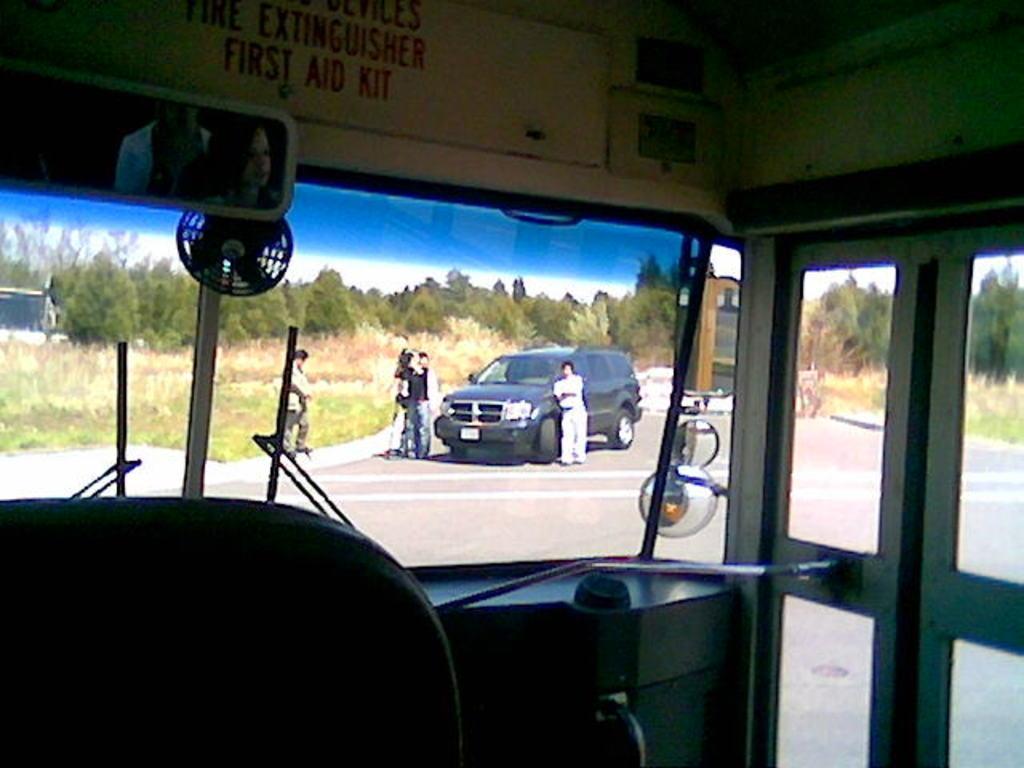Can you describe this image briefly? In this image we can see an inside view of a vehicle. In the center of the image we can see a car parked on road, a group of persons standing. In the background, we can see a group of trees and the sky. 